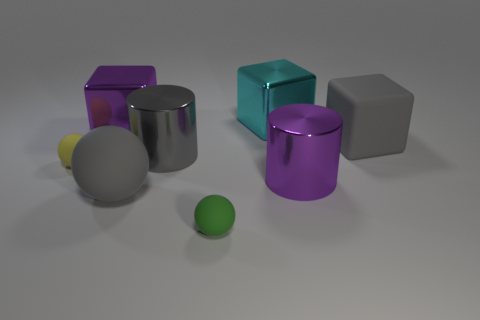Is the material of the small sphere on the right side of the small yellow object the same as the cube that is on the right side of the cyan block?
Your answer should be very brief. Yes. What is the shape of the purple shiny thing right of the large purple shiny thing that is left of the big purple cylinder?
Your response must be concise. Cylinder. What color is the large sphere that is made of the same material as the tiny yellow ball?
Keep it short and to the point. Gray. Do the big sphere and the big rubber cube have the same color?
Provide a succinct answer. Yes. What shape is the green thing that is the same size as the yellow ball?
Provide a succinct answer. Sphere. The gray metallic object is what size?
Provide a succinct answer. Large. Do the purple metallic thing that is behind the yellow rubber ball and the yellow ball that is on the left side of the gray matte sphere have the same size?
Ensure brevity in your answer.  No. What is the color of the ball that is left of the gray matte thing that is left of the big gray block?
Your answer should be compact. Yellow. There is a gray cylinder that is the same size as the gray matte cube; what is its material?
Provide a succinct answer. Metal. How many metallic things are purple cylinders or large yellow cubes?
Provide a short and direct response. 1. 